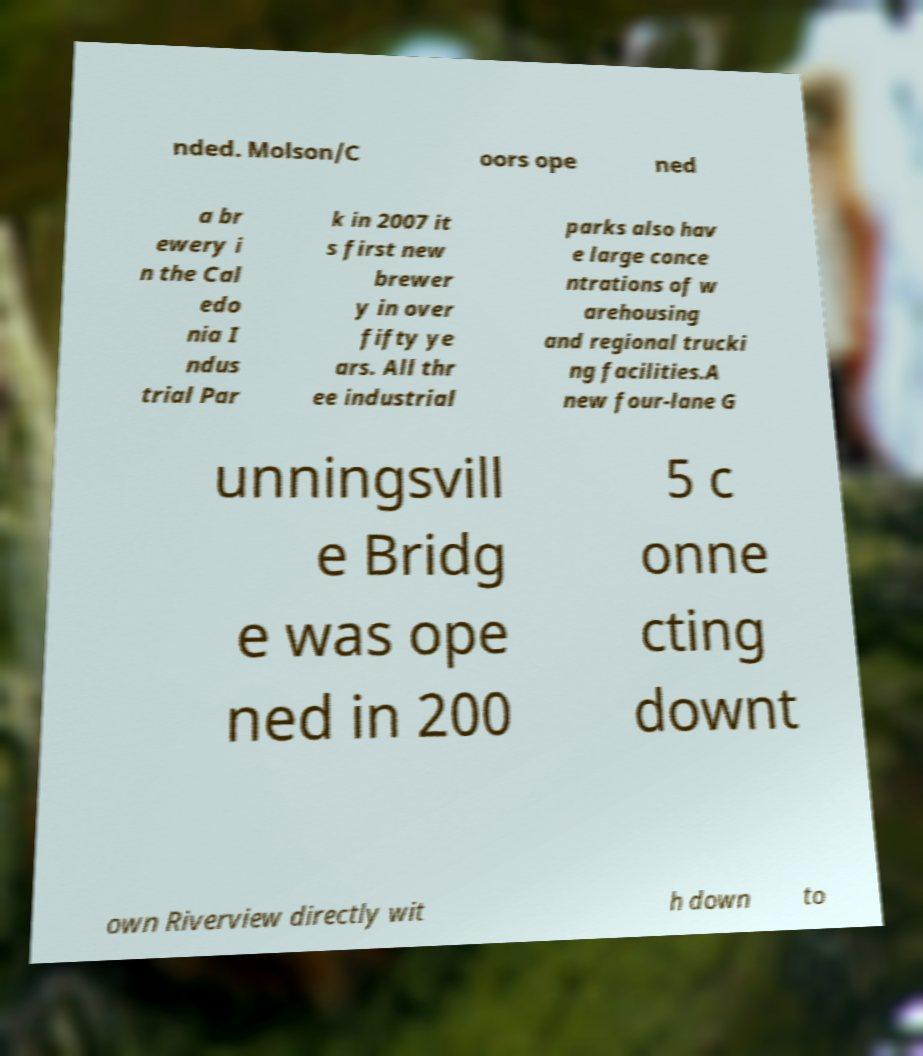Please identify and transcribe the text found in this image. nded. Molson/C oors ope ned a br ewery i n the Cal edo nia I ndus trial Par k in 2007 it s first new brewer y in over fifty ye ars. All thr ee industrial parks also hav e large conce ntrations of w arehousing and regional trucki ng facilities.A new four-lane G unningsvill e Bridg e was ope ned in 200 5 c onne cting downt own Riverview directly wit h down to 